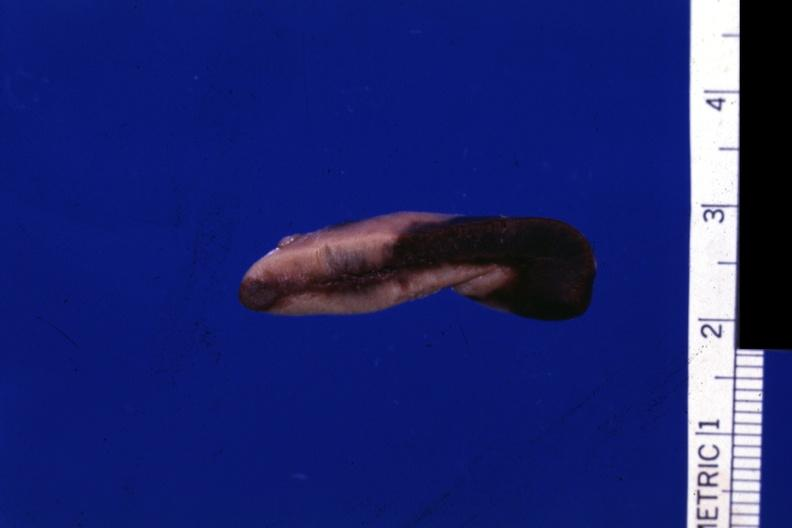what does this image show?
Answer the question using a single word or phrase. Fixed tissue close-up view typical early hemorrhage in cortex 